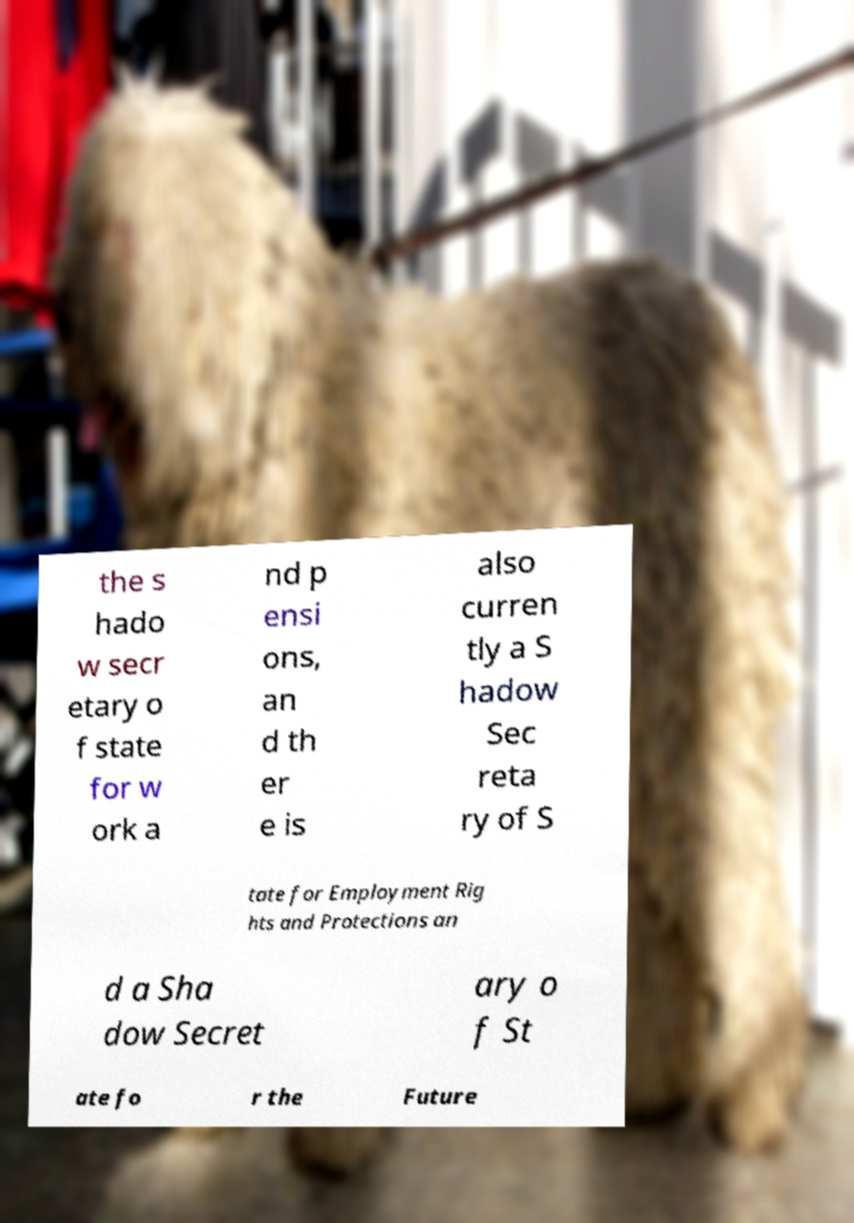What messages or text are displayed in this image? I need them in a readable, typed format. the s hado w secr etary o f state for w ork a nd p ensi ons, an d th er e is also curren tly a S hadow Sec reta ry of S tate for Employment Rig hts and Protections an d a Sha dow Secret ary o f St ate fo r the Future 